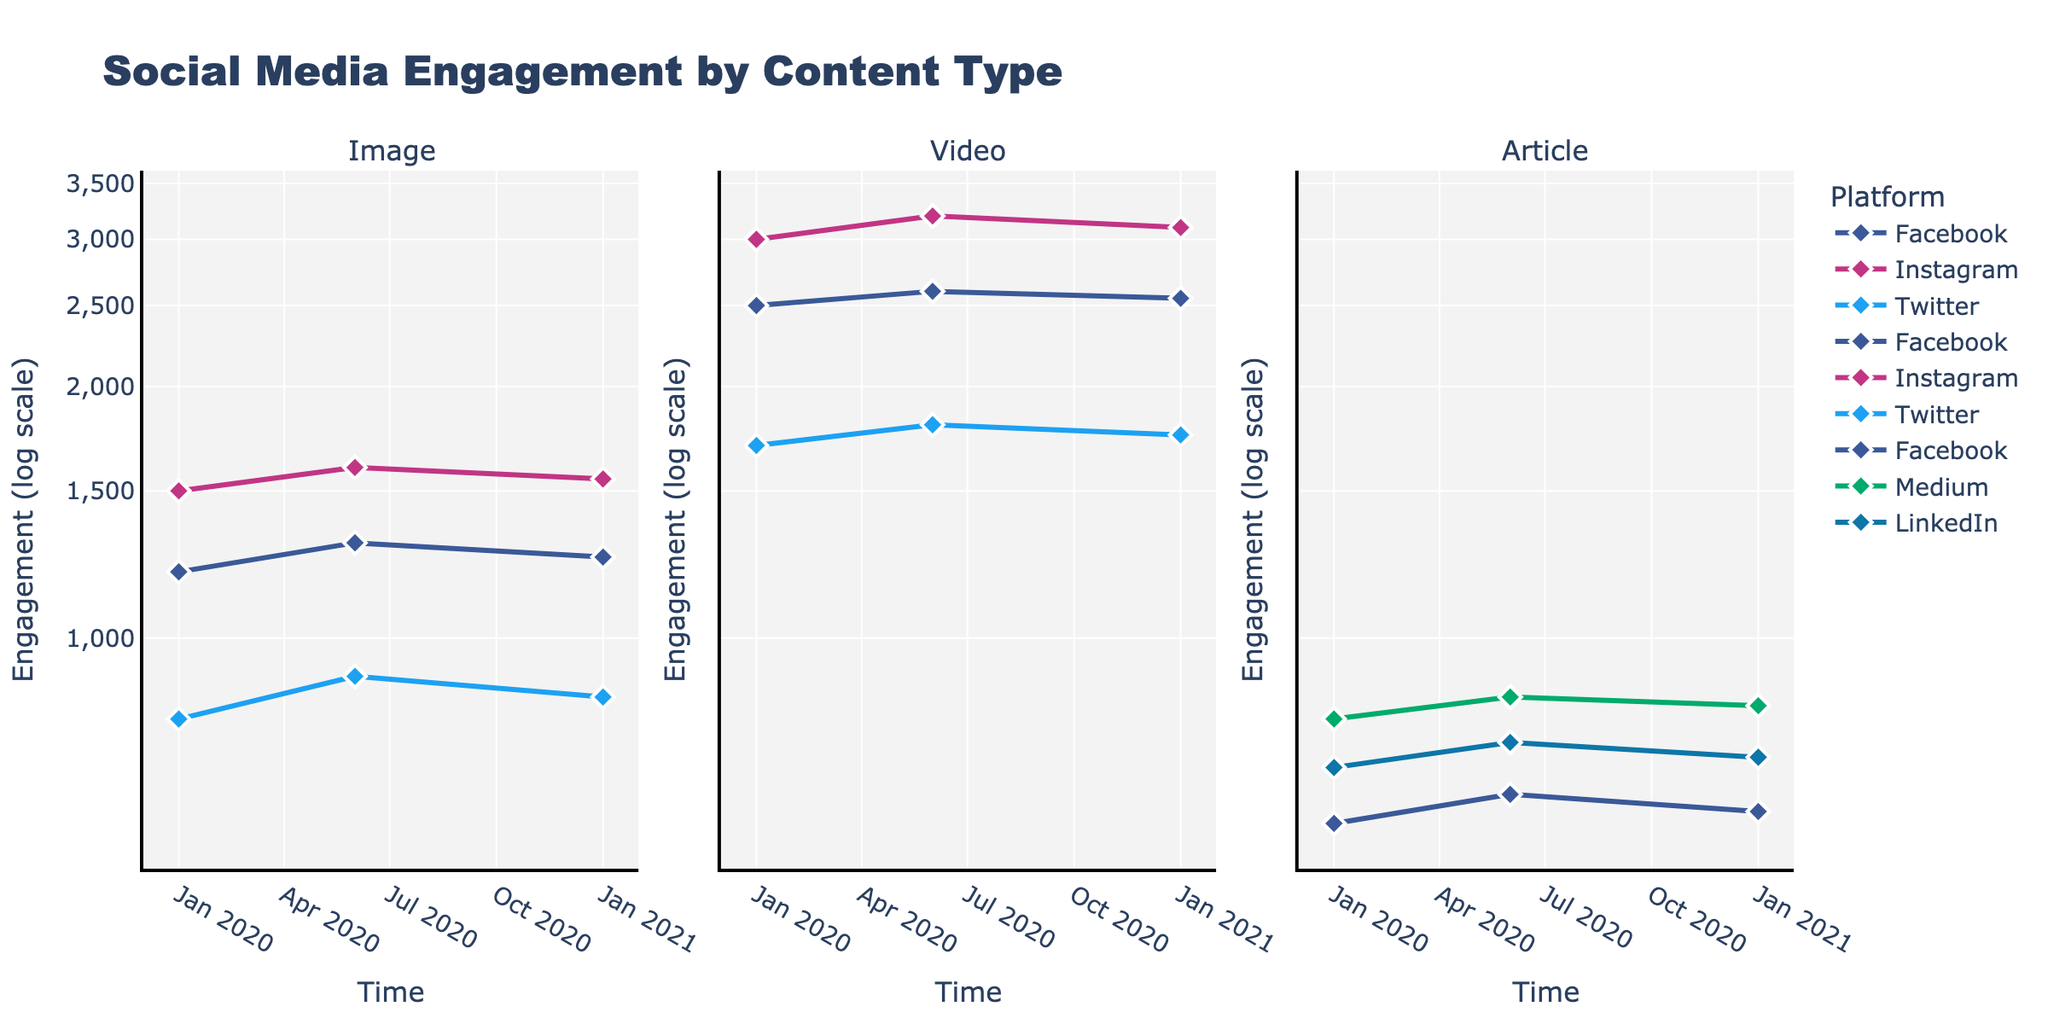How many platforms are depicted for the "Image" content type? Look at the "Image" subplot and count the distinct lines, each representing a platform.
Answer: 3 Which platform has the highest engagement for "Videos" on January 1, 2020? Identify the data points for January 1, 2020, in the "Videos" subplot and compare the engagement values to find the highest one.
Answer: Instagram What is the engagement difference between "Facebook" and "Twitter" for "Images" on June 1, 2020? Find the engagement values for "Facebook" and "Twitter" on June 1, 2020, in the "Images" subplot and calculate the difference: 1300 (Facebook) - 900 (Twitter)
Answer: 400 Which content type experienced the most consistent engagement trend over the periods shown? Examine the line patterns in each subplot for smoothness and consistency across different times.
Answer: Article In which period do we see the most significant engagement drop for "Articles" on Facebook? Analyze the "Articles" subplot and identify where the largest drop in engagement occurs by comparing values across different periods.
Answer: 2021-01-01 How does the engagement for "Facebook" compare between "Images" and "Videos" on January 1, 2021? Compare the "Images" and "Videos" subplots for January 1, 2021, and find the engagement values for "Facebook" in each subplot: 1250 (Images) and 2550 (Videos)
Answer: Videos are higher Which platform showed an increasing trend for "Articles" between the periods shown? Look at the "Articles" subplot and identify which platform's engagement increased over time.
Answer: Medium What are the visual markers used to represent data points in the figure? Identify the shapes of the markers used in the plots.
Answer: Diamond Are the engagement levels for "Twitter" growing, shrinking, or stable over time for "Videos"? Check the data points for "Videos" on "Twitter" across different periods and determine the trend direction.
Answer: Stable What is the engagement difference between LinkedIn and Medium for "Articles" on June 1, 2020? Look at the "Articles" subplot data points for June 1, 2020, and calculate the engagement difference: 850 (Medium) - 750 (LinkedIn)
Answer: 100 